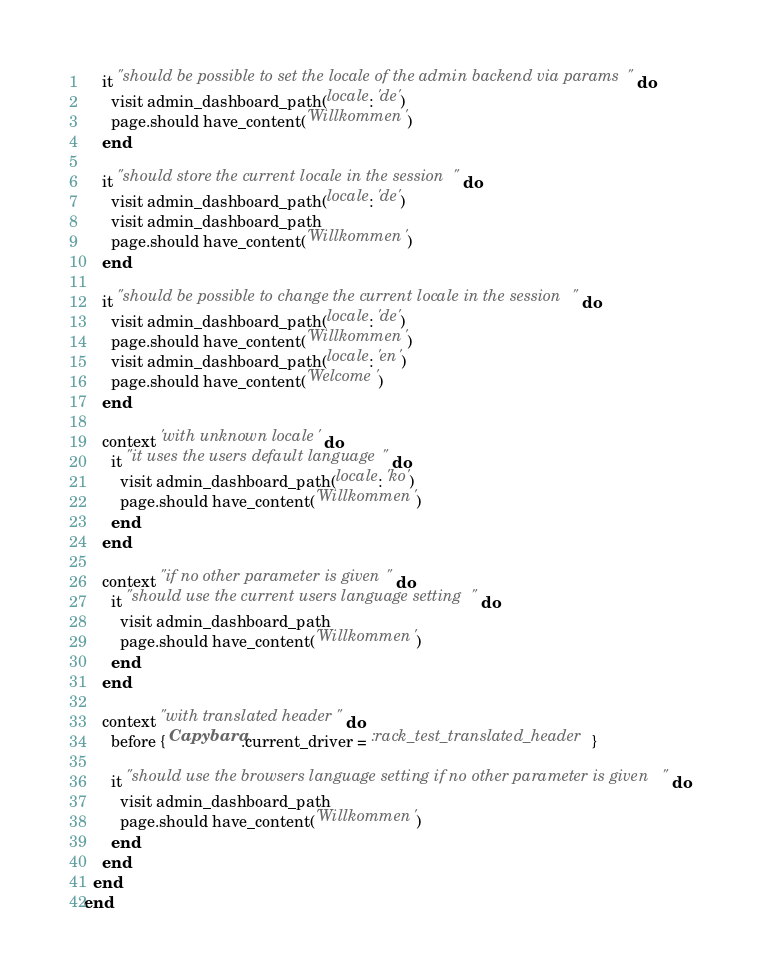Convert code to text. <code><loc_0><loc_0><loc_500><loc_500><_Ruby_>
    it "should be possible to set the locale of the admin backend via params" do
      visit admin_dashboard_path(locale: 'de')
      page.should have_content('Willkommen')
    end

    it "should store the current locale in the session" do
      visit admin_dashboard_path(locale: 'de')
      visit admin_dashboard_path
      page.should have_content('Willkommen')
    end

    it "should be possible to change the current locale in the session" do
      visit admin_dashboard_path(locale: 'de')
      page.should have_content('Willkommen')
      visit admin_dashboard_path(locale: 'en')
      page.should have_content('Welcome')
    end

    context 'with unknown locale' do
      it "it uses the users default language" do
        visit admin_dashboard_path(locale: 'ko')
        page.should have_content('Willkommen')
      end
    end

    context "if no other parameter is given" do
      it "should use the current users language setting" do
        visit admin_dashboard_path
        page.should have_content('Willkommen')
      end
    end

    context "with translated header" do
      before { Capybara.current_driver = :rack_test_translated_header }

      it "should use the browsers language setting if no other parameter is given" do
        visit admin_dashboard_path
        page.should have_content('Willkommen')
      end
    end
  end
end
</code> 